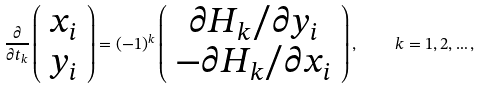Convert formula to latex. <formula><loc_0><loc_0><loc_500><loc_500>\frac { \partial } { \partial t _ { k } } \left ( \begin{array} { c } x _ { i } \\ y _ { i } \end{array} \right ) = ( - 1 ) ^ { k } \left ( \begin{array} { c } \partial H _ { k } / \partial y _ { i } \\ - \partial H _ { k } / \partial x _ { i } \end{array} \right ) , \quad k = 1 , 2 , \dots ,</formula> 